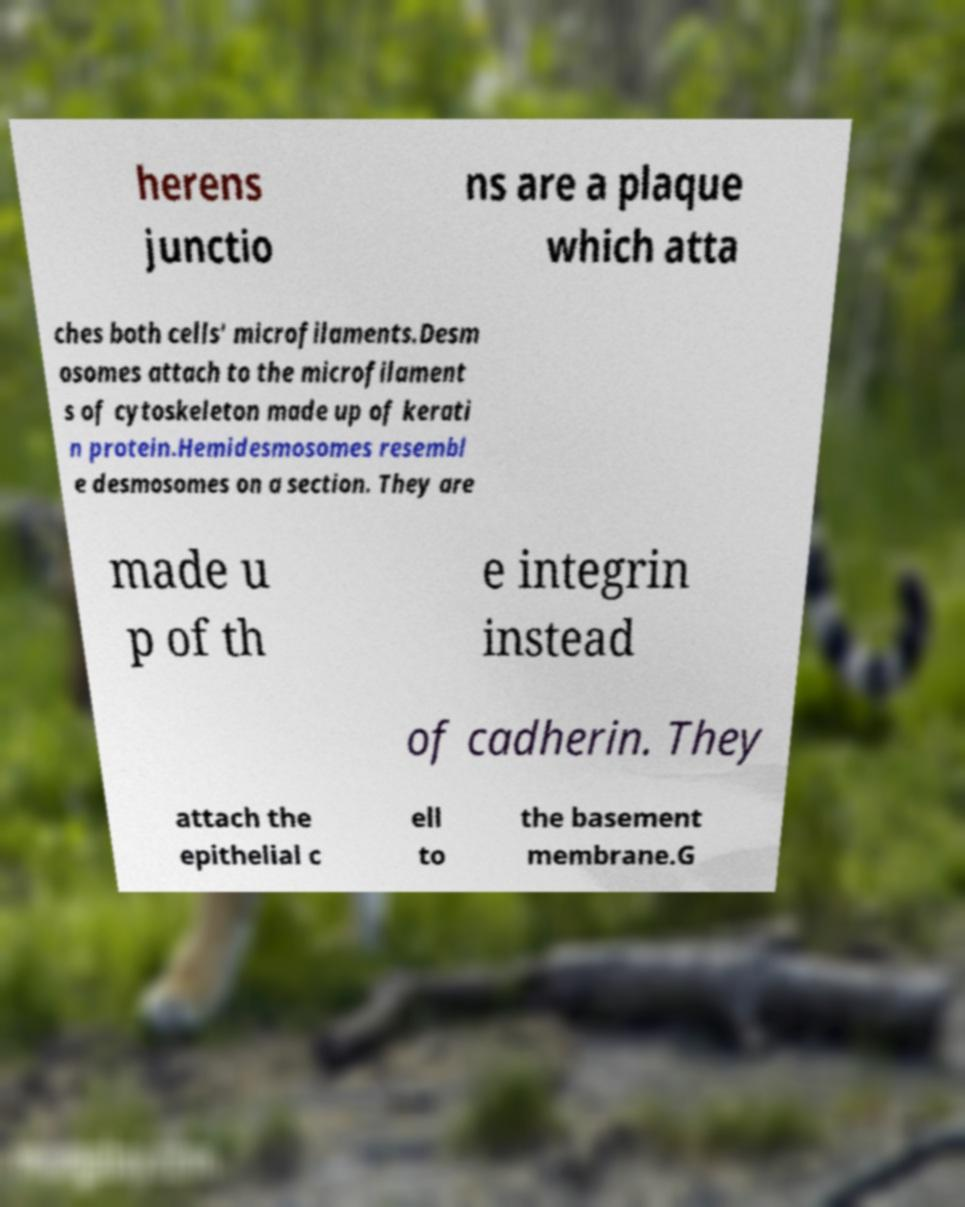Please identify and transcribe the text found in this image. herens junctio ns are a plaque which atta ches both cells' microfilaments.Desm osomes attach to the microfilament s of cytoskeleton made up of kerati n protein.Hemidesmosomes resembl e desmosomes on a section. They are made u p of th e integrin instead of cadherin. They attach the epithelial c ell to the basement membrane.G 